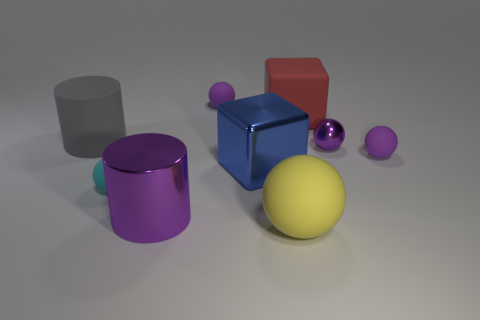Subtract all big spheres. How many spheres are left? 4 Subtract all yellow blocks. How many purple spheres are left? 3 Subtract 2 spheres. How many spheres are left? 3 Add 1 yellow rubber objects. How many objects exist? 10 Subtract all cyan balls. How many balls are left? 4 Subtract all cyan balls. Subtract all red cylinders. How many balls are left? 4 Subtract all big yellow matte cylinders. Subtract all large shiny cylinders. How many objects are left? 8 Add 8 big gray cylinders. How many big gray cylinders are left? 9 Add 2 tiny brown rubber objects. How many tiny brown rubber objects exist? 2 Subtract 0 red balls. How many objects are left? 9 